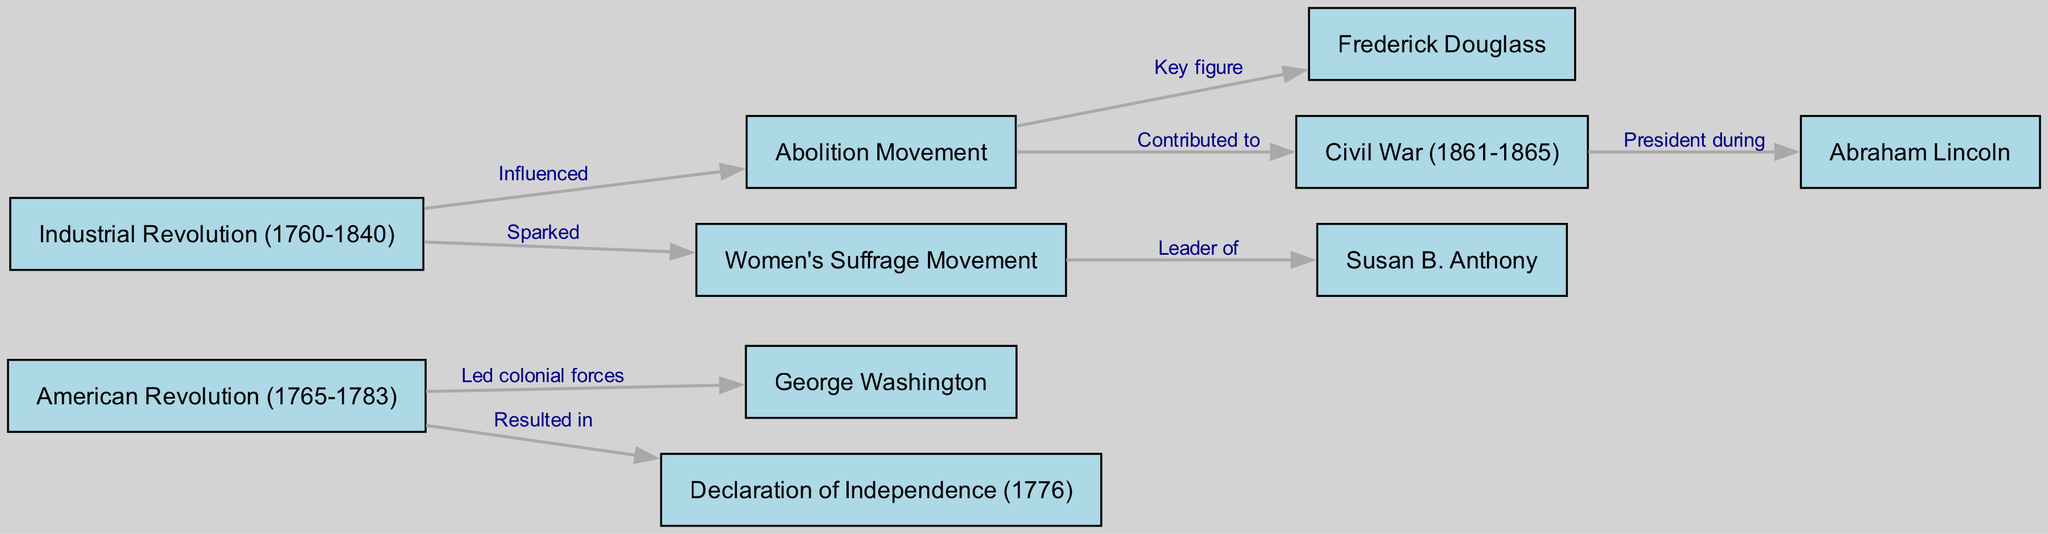What historical event is connected to George Washington? The diagram shows an edge labeled "Led colonial forces" connecting George Washington to the American Revolution, indicating that he was involved in the event.
Answer: American Revolution How many nodes are in the diagram? The diagram lists a total of 10 distinct nodes representing various historical events, figures, and movements in the region's history.
Answer: 10 Who is the key figure in the Abolition Movement? The edge labeled "Key figure" connects the Abolition Movement to Frederick Douglass, highlighting him as a prominent individual associated with this movement in history.
Answer: Frederick Douglass What resulted from the American Revolution? The diagram indicates a relationship labeled "Resulted in" between the American Revolution and the Declaration of Independence, illustrating that the former led to the latter.
Answer: Declaration of Independence Which movement was sparked by the Industrial Revolution? The edge between the Industrial Revolution and the Women's Suffrage Movement is labeled "Sparked," suggesting a connection where societal changes from the Industrial Revolution led to the initiation of the Women's Suffrage Movement.
Answer: Women's Suffrage Movement Who was president during the Civil War? According to the diagram, Abraham Lincoln is linked by the edge labeled "President during" to the Civil War, confirming his presidency during that historical period.
Answer: Abraham Lincoln What historical event did Susan B. Anthony lead? The diagram shows Susan B. Anthony connected to the Women's Suffrage Movement with the edge labeled "Leader of," indicating her leadership role within that movement.
Answer: Women's Suffrage Movement What societal change contributed to the Civil War? The diagram demonstrates that the Abolition Movement is linked with the label "Contributed to" the Civil War, suggesting the influence of the Abolition Movement on the conflict.
Answer: Abolition Movement Which historical figure is associated with the Declaration of Independence? The American Revolution led to the Declaration of Independence, but no direct connection to a key historical figure is shown with the declaration in this particular diagram. Therefore, looking for a direct figure related to this declaration would not yield an answer in this diagram context.
Answer: None 